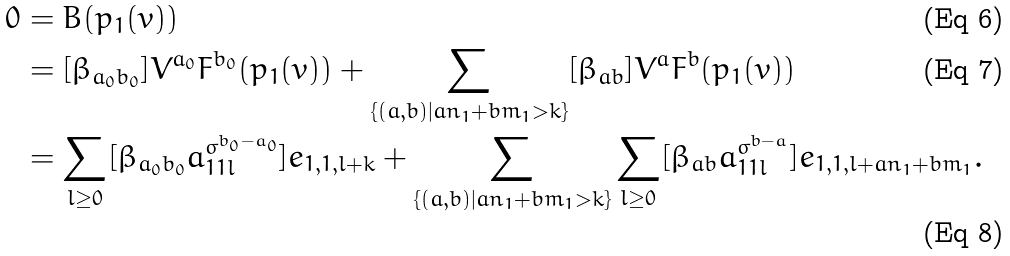Convert formula to latex. <formula><loc_0><loc_0><loc_500><loc_500>0 & = B ( p _ { 1 } ( v ) ) \\ & = [ \beta _ { a _ { 0 } b _ { 0 } } ] V ^ { a _ { 0 } } F ^ { b _ { 0 } } ( p _ { 1 } ( v ) ) + \sum _ { \{ ( a , b ) | a n _ { 1 } + b m _ { 1 } > k \} } [ \beta _ { a b } ] V ^ { a } F ^ { b } ( p _ { 1 } ( v ) ) \\ & = \sum _ { l \geq 0 } [ \beta _ { a _ { 0 } b _ { 0 } } a _ { 1 1 l } ^ { \sigma ^ { b _ { 0 } - a _ { 0 } } } ] e _ { 1 , 1 , l + k } + \sum _ { \{ ( a , b ) | a n _ { 1 } + b m _ { 1 } > k \} } \sum _ { l \geq 0 } [ \beta _ { a b } a _ { 1 1 l } ^ { \sigma ^ { b - a } } ] e _ { 1 , 1 , l + a n _ { 1 } + b m _ { 1 } } .</formula> 